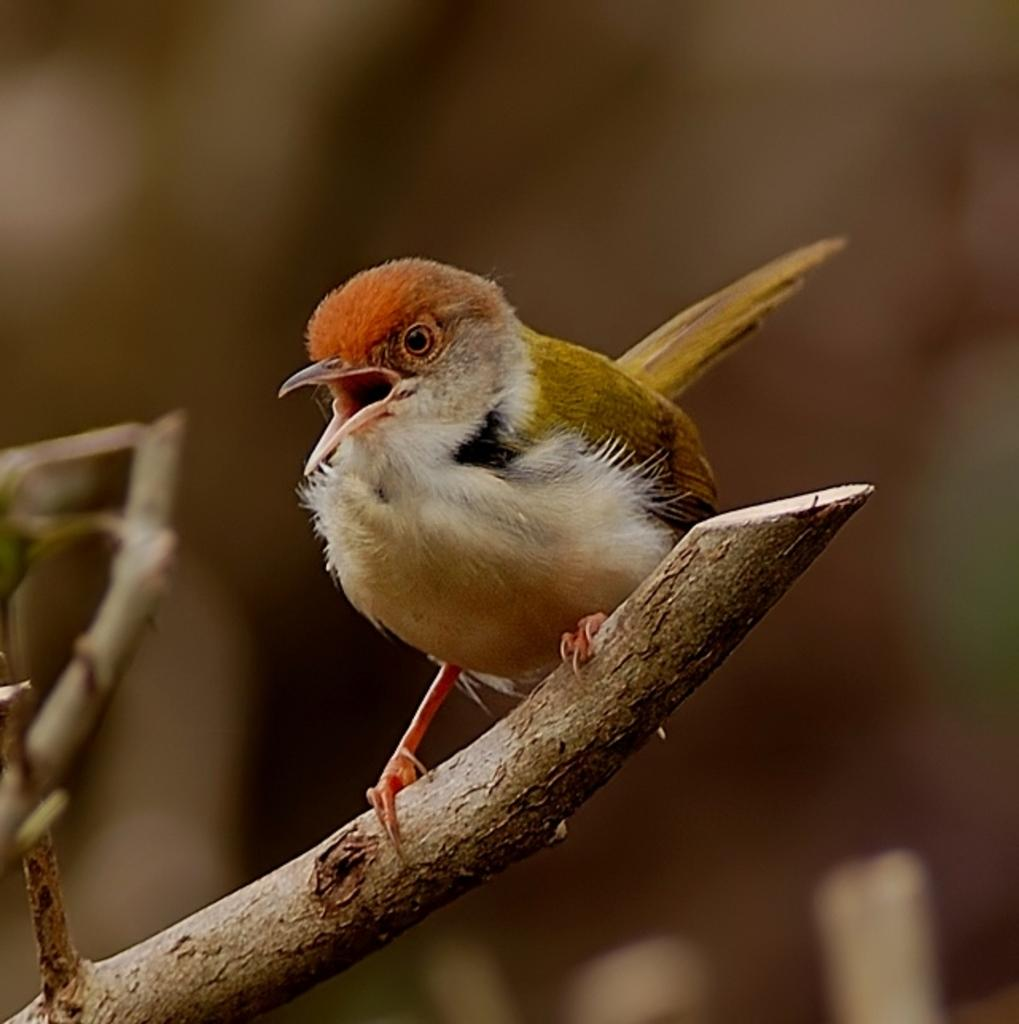What is the main subject of the picture? The main subject of the picture is a bird. Where is the bird located in the picture? The bird is sitting on a tree. What color is the bird's body? The bird has a white body. What colors are present on the top part of the bird's body? The bird has green and orange color on the top part of its body. What type of hair can be seen on the bird in the image? There is no hair present on the bird in the image, as birds do not have hair. 